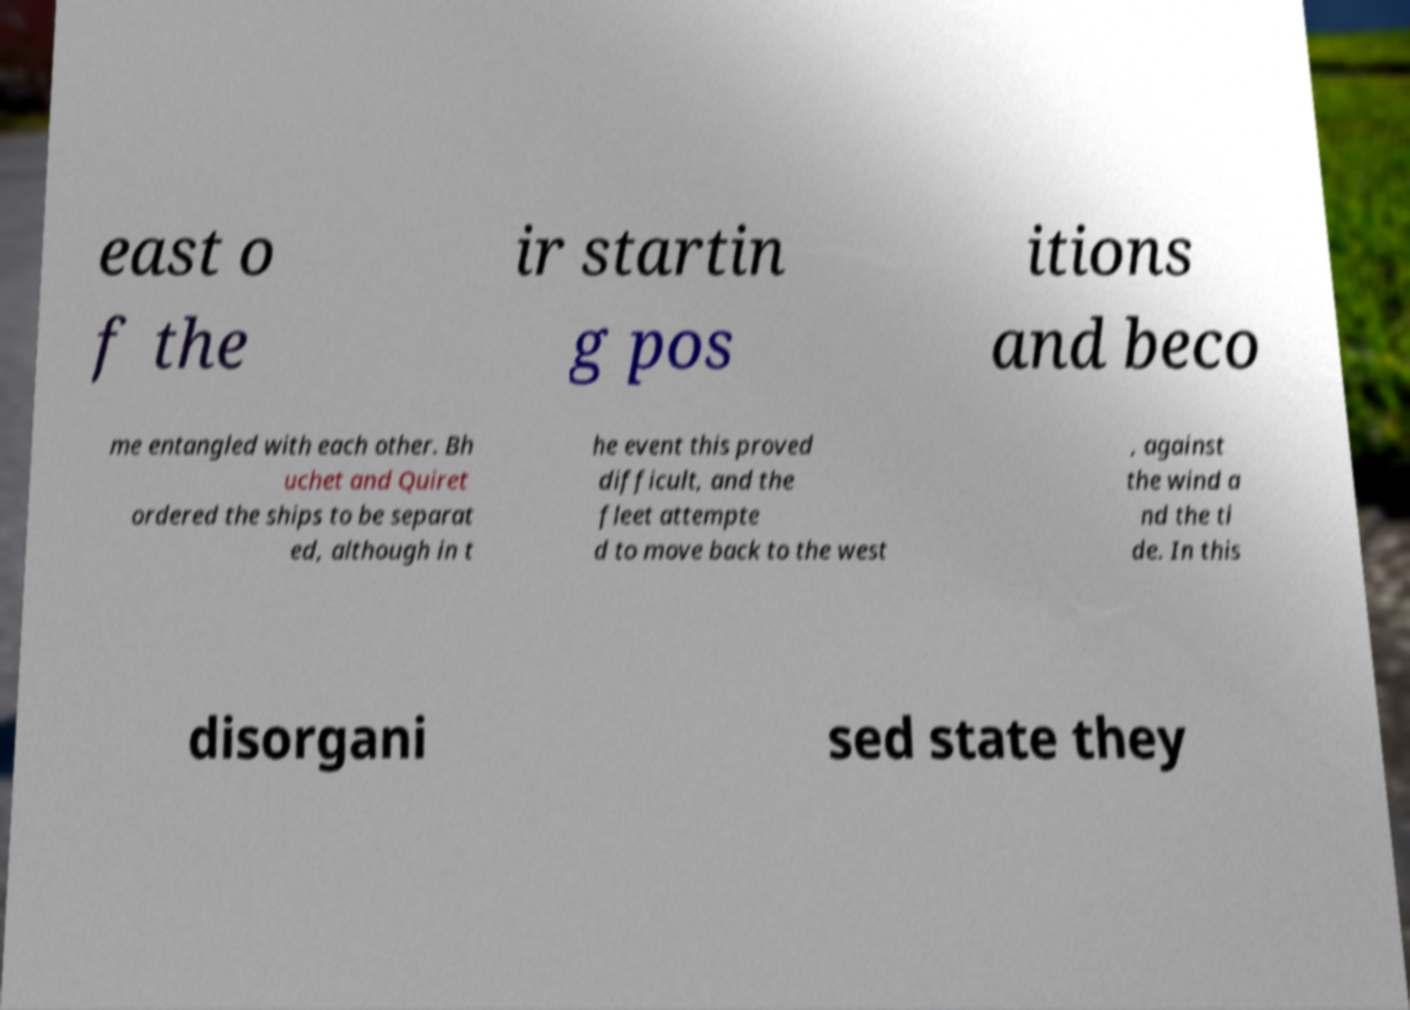Can you accurately transcribe the text from the provided image for me? east o f the ir startin g pos itions and beco me entangled with each other. Bh uchet and Quiret ordered the ships to be separat ed, although in t he event this proved difficult, and the fleet attempte d to move back to the west , against the wind a nd the ti de. In this disorgani sed state they 